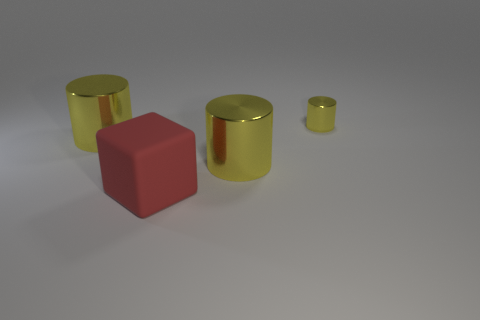What is the size of the yellow cylinder right of the metallic thing that is in front of the big yellow cylinder that is to the left of the rubber thing?
Your answer should be very brief. Small. There is a shiny cylinder that is behind the thing to the left of the rubber cube; how big is it?
Make the answer very short. Small. What color is the cube?
Keep it short and to the point. Red. There is a large cylinder on the left side of the large red object; how many big shiny cylinders are on the left side of it?
Provide a succinct answer. 0. Is there a tiny thing behind the metal cylinder that is on the left side of the rubber cube?
Offer a very short reply. Yes. Are there any red rubber blocks to the right of the large red matte object?
Offer a very short reply. No. Is the shape of the large yellow metallic thing that is left of the big red rubber cube the same as  the tiny metallic object?
Make the answer very short. Yes. How many other shiny objects have the same shape as the small thing?
Your response must be concise. 2. Are there any cylinders that have the same material as the red object?
Your answer should be compact. No. What material is the yellow thing that is behind the big yellow metal cylinder that is left of the red cube?
Ensure brevity in your answer.  Metal. 